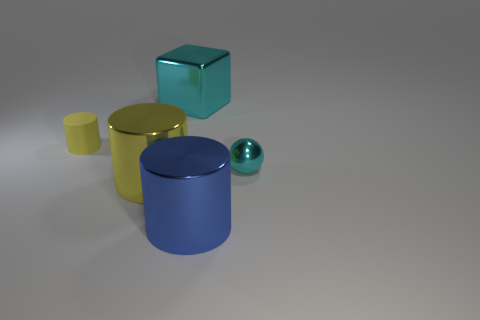Subtract all blue shiny cylinders. How many cylinders are left? 2 Subtract all cyan balls. How many yellow cylinders are left? 2 Add 1 large brown metallic cylinders. How many objects exist? 6 Subtract 1 cylinders. How many cylinders are left? 2 Add 5 large cyan objects. How many large cyan objects are left? 6 Add 4 big metal blocks. How many big metal blocks exist? 5 Subtract 1 blue cylinders. How many objects are left? 4 Subtract all cubes. How many objects are left? 4 Subtract all red cylinders. Subtract all yellow blocks. How many cylinders are left? 3 Subtract all purple metal cubes. Subtract all cyan metallic objects. How many objects are left? 3 